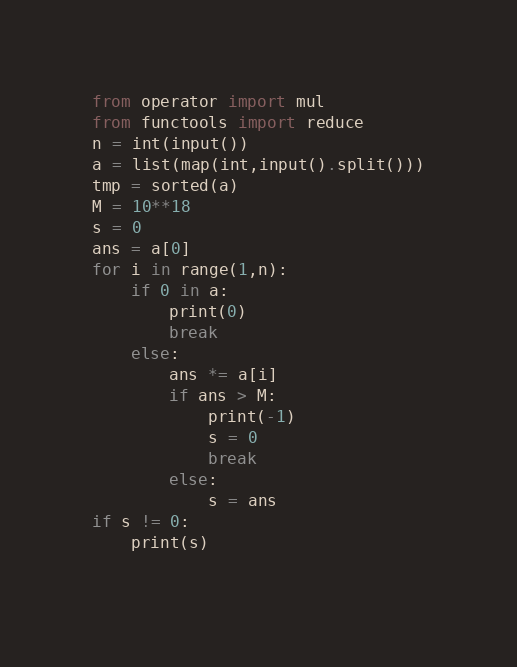<code> <loc_0><loc_0><loc_500><loc_500><_Python_>from operator import mul
from functools import reduce
n = int(input())
a = list(map(int,input().split()))
tmp = sorted(a)
M = 10**18
s = 0
ans = a[0]
for i in range(1,n):
	if 0 in a:
		print(0)
		break
	else:
		ans *= a[i]
		if ans > M:
			print(-1)
			s = 0
			break
		else:
			s = ans
if s != 0:
	print(s)
   </code> 